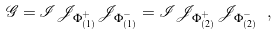Convert formula to latex. <formula><loc_0><loc_0><loc_500><loc_500>\mathcal { G } = \mathcal { I } \mathcal { J } _ { \Phi ^ { + } _ { ( 1 ) } } \mathcal { J } _ { \Phi ^ { - } _ { ( 1 ) } } = \mathcal { I } \mathcal { J } _ { \Phi ^ { + } _ { ( 2 ) } } \mathcal { J } _ { \Phi ^ { - } _ { ( 2 ) } } \ ,</formula> 